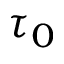Convert formula to latex. <formula><loc_0><loc_0><loc_500><loc_500>\tau _ { 0 }</formula> 